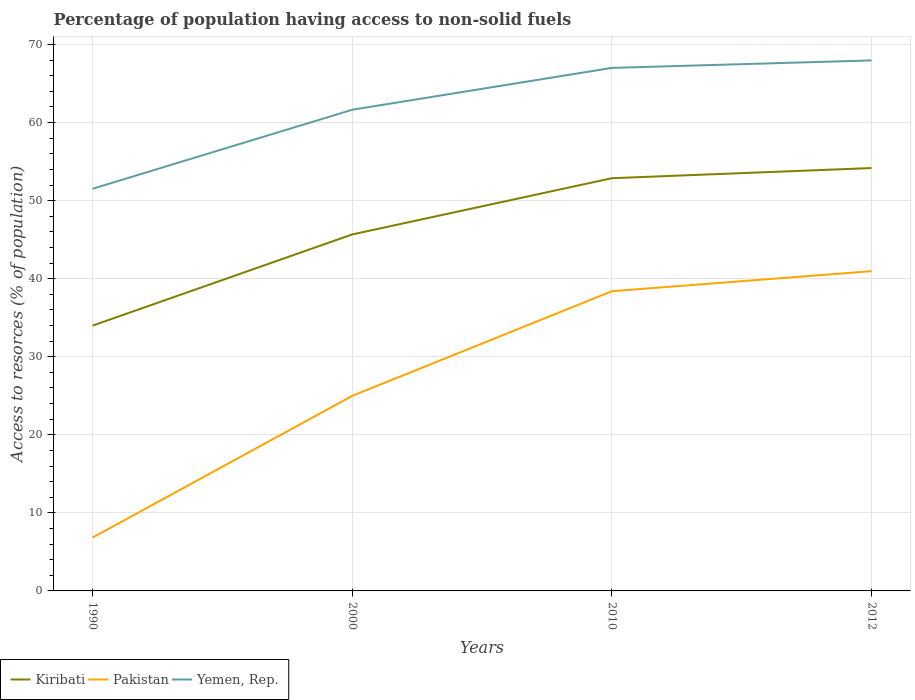Is the number of lines equal to the number of legend labels?
Keep it short and to the point. Yes. Across all years, what is the maximum percentage of population having access to non-solid fuels in Yemen, Rep.?
Provide a short and direct response. 51.52. What is the total percentage of population having access to non-solid fuels in Yemen, Rep. in the graph?
Offer a very short reply. -6.32. What is the difference between the highest and the second highest percentage of population having access to non-solid fuels in Pakistan?
Give a very brief answer. 34.12. How many lines are there?
Keep it short and to the point. 3. Are the values on the major ticks of Y-axis written in scientific E-notation?
Provide a short and direct response. No. Does the graph contain grids?
Provide a short and direct response. Yes. How many legend labels are there?
Your response must be concise. 3. What is the title of the graph?
Provide a succinct answer. Percentage of population having access to non-solid fuels. Does "Estonia" appear as one of the legend labels in the graph?
Ensure brevity in your answer.  No. What is the label or title of the Y-axis?
Offer a very short reply. Access to resorces (% of population). What is the Access to resorces (% of population) in Kiribati in 1990?
Ensure brevity in your answer.  33.99. What is the Access to resorces (% of population) in Pakistan in 1990?
Give a very brief answer. 6.84. What is the Access to resorces (% of population) of Yemen, Rep. in 1990?
Provide a short and direct response. 51.52. What is the Access to resorces (% of population) of Kiribati in 2000?
Offer a terse response. 45.67. What is the Access to resorces (% of population) in Pakistan in 2000?
Your answer should be compact. 25. What is the Access to resorces (% of population) of Yemen, Rep. in 2000?
Keep it short and to the point. 61.64. What is the Access to resorces (% of population) of Kiribati in 2010?
Offer a very short reply. 52.87. What is the Access to resorces (% of population) in Pakistan in 2010?
Provide a short and direct response. 38.4. What is the Access to resorces (% of population) in Yemen, Rep. in 2010?
Keep it short and to the point. 67. What is the Access to resorces (% of population) in Kiribati in 2012?
Provide a succinct answer. 54.17. What is the Access to resorces (% of population) in Pakistan in 2012?
Your answer should be compact. 40.96. What is the Access to resorces (% of population) of Yemen, Rep. in 2012?
Your response must be concise. 67.96. Across all years, what is the maximum Access to resorces (% of population) of Kiribati?
Keep it short and to the point. 54.17. Across all years, what is the maximum Access to resorces (% of population) in Pakistan?
Give a very brief answer. 40.96. Across all years, what is the maximum Access to resorces (% of population) of Yemen, Rep.?
Ensure brevity in your answer.  67.96. Across all years, what is the minimum Access to resorces (% of population) of Kiribati?
Ensure brevity in your answer.  33.99. Across all years, what is the minimum Access to resorces (% of population) in Pakistan?
Your response must be concise. 6.84. Across all years, what is the minimum Access to resorces (% of population) of Yemen, Rep.?
Provide a succinct answer. 51.52. What is the total Access to resorces (% of population) in Kiribati in the graph?
Your answer should be compact. 186.7. What is the total Access to resorces (% of population) of Pakistan in the graph?
Give a very brief answer. 111.2. What is the total Access to resorces (% of population) in Yemen, Rep. in the graph?
Keep it short and to the point. 248.13. What is the difference between the Access to resorces (% of population) in Kiribati in 1990 and that in 2000?
Provide a short and direct response. -11.68. What is the difference between the Access to resorces (% of population) in Pakistan in 1990 and that in 2000?
Your response must be concise. -18.15. What is the difference between the Access to resorces (% of population) of Yemen, Rep. in 1990 and that in 2000?
Ensure brevity in your answer.  -10.12. What is the difference between the Access to resorces (% of population) in Kiribati in 1990 and that in 2010?
Give a very brief answer. -18.88. What is the difference between the Access to resorces (% of population) of Pakistan in 1990 and that in 2010?
Provide a short and direct response. -31.55. What is the difference between the Access to resorces (% of population) in Yemen, Rep. in 1990 and that in 2010?
Ensure brevity in your answer.  -15.48. What is the difference between the Access to resorces (% of population) of Kiribati in 1990 and that in 2012?
Your response must be concise. -20.18. What is the difference between the Access to resorces (% of population) of Pakistan in 1990 and that in 2012?
Your response must be concise. -34.12. What is the difference between the Access to resorces (% of population) of Yemen, Rep. in 1990 and that in 2012?
Offer a terse response. -16.44. What is the difference between the Access to resorces (% of population) in Kiribati in 2000 and that in 2010?
Provide a succinct answer. -7.2. What is the difference between the Access to resorces (% of population) in Pakistan in 2000 and that in 2010?
Your answer should be very brief. -13.4. What is the difference between the Access to resorces (% of population) in Yemen, Rep. in 2000 and that in 2010?
Offer a terse response. -5.36. What is the difference between the Access to resorces (% of population) of Kiribati in 2000 and that in 2012?
Provide a short and direct response. -8.5. What is the difference between the Access to resorces (% of population) of Pakistan in 2000 and that in 2012?
Make the answer very short. -15.97. What is the difference between the Access to resorces (% of population) of Yemen, Rep. in 2000 and that in 2012?
Your answer should be compact. -6.32. What is the difference between the Access to resorces (% of population) of Kiribati in 2010 and that in 2012?
Keep it short and to the point. -1.3. What is the difference between the Access to resorces (% of population) of Pakistan in 2010 and that in 2012?
Keep it short and to the point. -2.57. What is the difference between the Access to resorces (% of population) in Yemen, Rep. in 2010 and that in 2012?
Make the answer very short. -0.96. What is the difference between the Access to resorces (% of population) of Kiribati in 1990 and the Access to resorces (% of population) of Pakistan in 2000?
Make the answer very short. 8.99. What is the difference between the Access to resorces (% of population) of Kiribati in 1990 and the Access to resorces (% of population) of Yemen, Rep. in 2000?
Ensure brevity in your answer.  -27.65. What is the difference between the Access to resorces (% of population) of Pakistan in 1990 and the Access to resorces (% of population) of Yemen, Rep. in 2000?
Make the answer very short. -54.8. What is the difference between the Access to resorces (% of population) in Kiribati in 1990 and the Access to resorces (% of population) in Pakistan in 2010?
Keep it short and to the point. -4.41. What is the difference between the Access to resorces (% of population) in Kiribati in 1990 and the Access to resorces (% of population) in Yemen, Rep. in 2010?
Provide a short and direct response. -33.01. What is the difference between the Access to resorces (% of population) of Pakistan in 1990 and the Access to resorces (% of population) of Yemen, Rep. in 2010?
Keep it short and to the point. -60.16. What is the difference between the Access to resorces (% of population) in Kiribati in 1990 and the Access to resorces (% of population) in Pakistan in 2012?
Your response must be concise. -6.97. What is the difference between the Access to resorces (% of population) of Kiribati in 1990 and the Access to resorces (% of population) of Yemen, Rep. in 2012?
Provide a short and direct response. -33.97. What is the difference between the Access to resorces (% of population) in Pakistan in 1990 and the Access to resorces (% of population) in Yemen, Rep. in 2012?
Give a very brief answer. -61.12. What is the difference between the Access to resorces (% of population) in Kiribati in 2000 and the Access to resorces (% of population) in Pakistan in 2010?
Give a very brief answer. 7.27. What is the difference between the Access to resorces (% of population) of Kiribati in 2000 and the Access to resorces (% of population) of Yemen, Rep. in 2010?
Offer a terse response. -21.33. What is the difference between the Access to resorces (% of population) in Pakistan in 2000 and the Access to resorces (% of population) in Yemen, Rep. in 2010?
Give a very brief answer. -42.01. What is the difference between the Access to resorces (% of population) of Kiribati in 2000 and the Access to resorces (% of population) of Pakistan in 2012?
Provide a succinct answer. 4.71. What is the difference between the Access to resorces (% of population) in Kiribati in 2000 and the Access to resorces (% of population) in Yemen, Rep. in 2012?
Your answer should be very brief. -22.29. What is the difference between the Access to resorces (% of population) of Pakistan in 2000 and the Access to resorces (% of population) of Yemen, Rep. in 2012?
Ensure brevity in your answer.  -42.96. What is the difference between the Access to resorces (% of population) in Kiribati in 2010 and the Access to resorces (% of population) in Pakistan in 2012?
Make the answer very short. 11.91. What is the difference between the Access to resorces (% of population) in Kiribati in 2010 and the Access to resorces (% of population) in Yemen, Rep. in 2012?
Ensure brevity in your answer.  -15.09. What is the difference between the Access to resorces (% of population) of Pakistan in 2010 and the Access to resorces (% of population) of Yemen, Rep. in 2012?
Your answer should be compact. -29.56. What is the average Access to resorces (% of population) in Kiribati per year?
Make the answer very short. 46.68. What is the average Access to resorces (% of population) of Pakistan per year?
Make the answer very short. 27.8. What is the average Access to resorces (% of population) of Yemen, Rep. per year?
Your response must be concise. 62.03. In the year 1990, what is the difference between the Access to resorces (% of population) of Kiribati and Access to resorces (% of population) of Pakistan?
Make the answer very short. 27.15. In the year 1990, what is the difference between the Access to resorces (% of population) of Kiribati and Access to resorces (% of population) of Yemen, Rep.?
Provide a short and direct response. -17.53. In the year 1990, what is the difference between the Access to resorces (% of population) in Pakistan and Access to resorces (% of population) in Yemen, Rep.?
Ensure brevity in your answer.  -44.68. In the year 2000, what is the difference between the Access to resorces (% of population) in Kiribati and Access to resorces (% of population) in Pakistan?
Provide a short and direct response. 20.67. In the year 2000, what is the difference between the Access to resorces (% of population) in Kiribati and Access to resorces (% of population) in Yemen, Rep.?
Your answer should be very brief. -15.97. In the year 2000, what is the difference between the Access to resorces (% of population) in Pakistan and Access to resorces (% of population) in Yemen, Rep.?
Your response must be concise. -36.65. In the year 2010, what is the difference between the Access to resorces (% of population) in Kiribati and Access to resorces (% of population) in Pakistan?
Your answer should be very brief. 14.48. In the year 2010, what is the difference between the Access to resorces (% of population) of Kiribati and Access to resorces (% of population) of Yemen, Rep.?
Offer a terse response. -14.13. In the year 2010, what is the difference between the Access to resorces (% of population) in Pakistan and Access to resorces (% of population) in Yemen, Rep.?
Your answer should be compact. -28.61. In the year 2012, what is the difference between the Access to resorces (% of population) of Kiribati and Access to resorces (% of population) of Pakistan?
Keep it short and to the point. 13.21. In the year 2012, what is the difference between the Access to resorces (% of population) of Kiribati and Access to resorces (% of population) of Yemen, Rep.?
Provide a short and direct response. -13.79. In the year 2012, what is the difference between the Access to resorces (% of population) of Pakistan and Access to resorces (% of population) of Yemen, Rep.?
Your response must be concise. -27. What is the ratio of the Access to resorces (% of population) of Kiribati in 1990 to that in 2000?
Ensure brevity in your answer.  0.74. What is the ratio of the Access to resorces (% of population) in Pakistan in 1990 to that in 2000?
Keep it short and to the point. 0.27. What is the ratio of the Access to resorces (% of population) in Yemen, Rep. in 1990 to that in 2000?
Your answer should be compact. 0.84. What is the ratio of the Access to resorces (% of population) in Kiribati in 1990 to that in 2010?
Keep it short and to the point. 0.64. What is the ratio of the Access to resorces (% of population) in Pakistan in 1990 to that in 2010?
Offer a terse response. 0.18. What is the ratio of the Access to resorces (% of population) of Yemen, Rep. in 1990 to that in 2010?
Make the answer very short. 0.77. What is the ratio of the Access to resorces (% of population) of Kiribati in 1990 to that in 2012?
Ensure brevity in your answer.  0.63. What is the ratio of the Access to resorces (% of population) in Pakistan in 1990 to that in 2012?
Ensure brevity in your answer.  0.17. What is the ratio of the Access to resorces (% of population) of Yemen, Rep. in 1990 to that in 2012?
Your answer should be compact. 0.76. What is the ratio of the Access to resorces (% of population) in Kiribati in 2000 to that in 2010?
Offer a very short reply. 0.86. What is the ratio of the Access to resorces (% of population) of Pakistan in 2000 to that in 2010?
Offer a terse response. 0.65. What is the ratio of the Access to resorces (% of population) of Yemen, Rep. in 2000 to that in 2010?
Give a very brief answer. 0.92. What is the ratio of the Access to resorces (% of population) in Kiribati in 2000 to that in 2012?
Provide a succinct answer. 0.84. What is the ratio of the Access to resorces (% of population) in Pakistan in 2000 to that in 2012?
Give a very brief answer. 0.61. What is the ratio of the Access to resorces (% of population) in Yemen, Rep. in 2000 to that in 2012?
Your answer should be very brief. 0.91. What is the ratio of the Access to resorces (% of population) of Pakistan in 2010 to that in 2012?
Keep it short and to the point. 0.94. What is the ratio of the Access to resorces (% of population) of Yemen, Rep. in 2010 to that in 2012?
Ensure brevity in your answer.  0.99. What is the difference between the highest and the second highest Access to resorces (% of population) of Pakistan?
Your answer should be compact. 2.57. What is the difference between the highest and the second highest Access to resorces (% of population) of Yemen, Rep.?
Ensure brevity in your answer.  0.96. What is the difference between the highest and the lowest Access to resorces (% of population) of Kiribati?
Offer a terse response. 20.18. What is the difference between the highest and the lowest Access to resorces (% of population) of Pakistan?
Offer a very short reply. 34.12. What is the difference between the highest and the lowest Access to resorces (% of population) of Yemen, Rep.?
Offer a terse response. 16.44. 